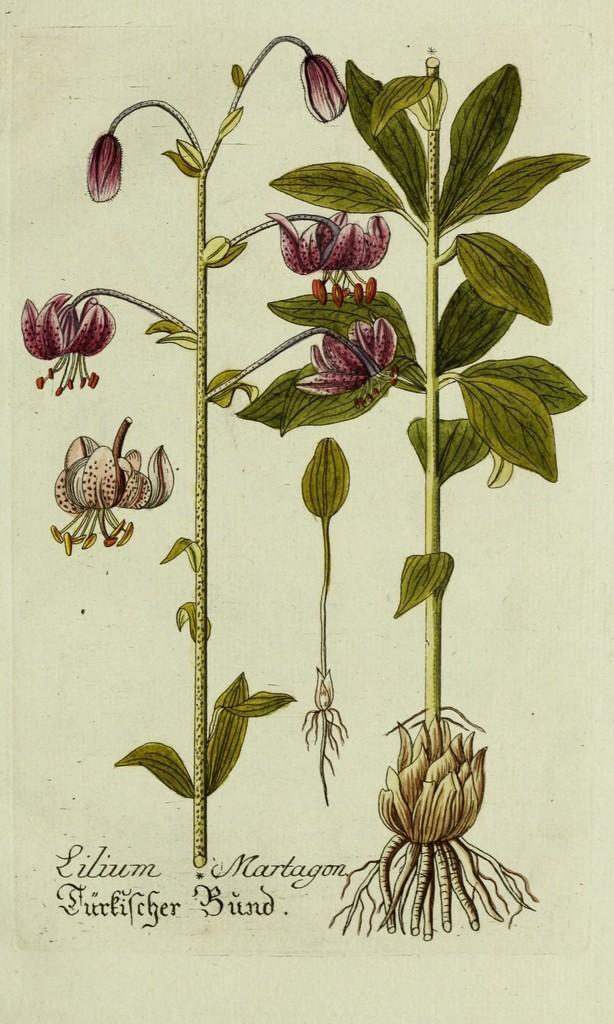How would you summarize this image in a sentence or two? In the image there is an art of two flower plants on a paper with some text below. 